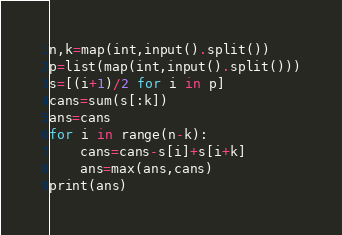<code> <loc_0><loc_0><loc_500><loc_500><_Python_>n,k=map(int,input().split())
p=list(map(int,input().split()))
s=[(i+1)/2 for i in p]
cans=sum(s[:k])
ans=cans
for i in range(n-k):
    cans=cans-s[i]+s[i+k]
    ans=max(ans,cans)
print(ans)</code> 